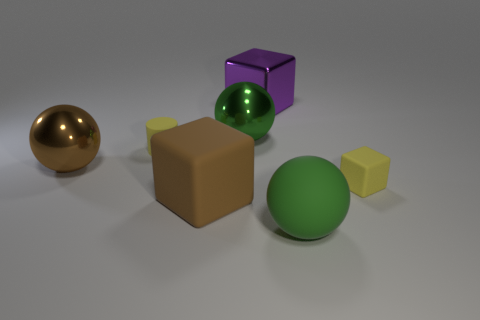What is the size of the yellow thing that is the same shape as the purple shiny object?
Provide a succinct answer. Small. There is a large brown thing that is on the left side of the brown block; what number of big purple blocks are behind it?
Provide a succinct answer. 1. Do the green ball that is in front of the small cylinder and the tiny thing that is to the left of the large green metallic object have the same material?
Ensure brevity in your answer.  Yes. How many tiny red matte things have the same shape as the green metallic thing?
Your answer should be compact. 0. What number of big rubber spheres have the same color as the cylinder?
Your answer should be very brief. 0. Is the shape of the large green object behind the yellow cylinder the same as the big shiny thing that is to the left of the cylinder?
Give a very brief answer. Yes. There is a tiny thing to the right of the large green ball in front of the brown ball; what number of small yellow rubber cylinders are behind it?
Ensure brevity in your answer.  1. What material is the big brown sphere that is in front of the tiny object on the left side of the small rubber thing that is in front of the small yellow matte cylinder?
Ensure brevity in your answer.  Metal. Do the block that is behind the small yellow rubber cube and the small yellow cube have the same material?
Offer a terse response. No. What number of matte cubes have the same size as the green rubber object?
Ensure brevity in your answer.  1. 